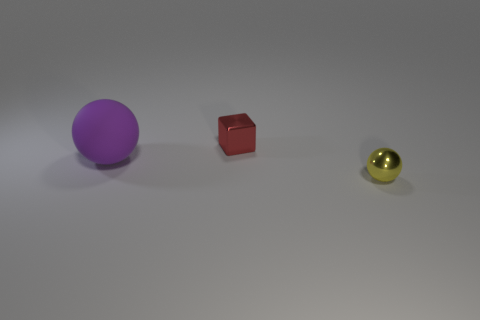Are there any tiny red metallic cubes right of the cube?
Offer a terse response. No. What number of purple things are small shiny cubes or rubber objects?
Give a very brief answer. 1. Is the material of the small red thing the same as the ball to the left of the small yellow object?
Your response must be concise. No. What size is the other object that is the same shape as the small yellow object?
Give a very brief answer. Large. What is the material of the tiny block?
Give a very brief answer. Metal. What material is the sphere that is left of the sphere right of the ball left of the small shiny sphere?
Ensure brevity in your answer.  Rubber. Does the ball left of the tiny yellow metal object have the same size as the sphere in front of the big purple matte sphere?
Offer a very short reply. No. What number of other things are the same material as the big purple object?
Provide a short and direct response. 0. How many metallic objects are either spheres or small red things?
Keep it short and to the point. 2. Are there fewer green matte things than tiny yellow balls?
Offer a very short reply. Yes. 